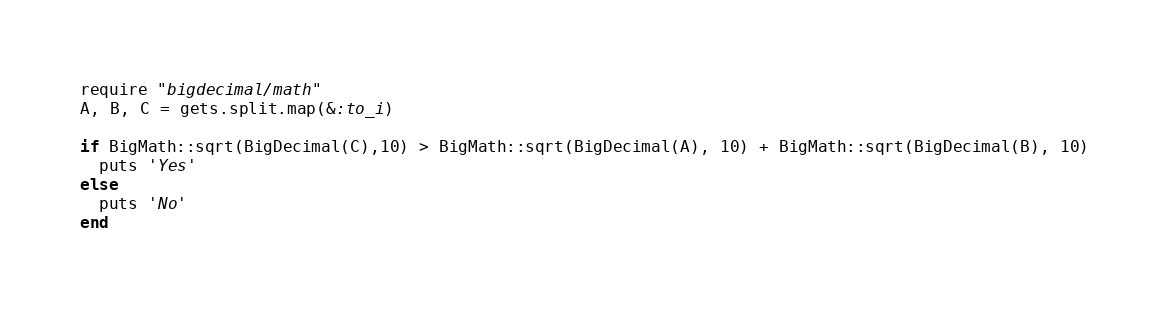Convert code to text. <code><loc_0><loc_0><loc_500><loc_500><_Ruby_>require "bigdecimal/math"
A, B, C = gets.split.map(&:to_i)

if BigMath::sqrt(BigDecimal(C),10) > BigMath::sqrt(BigDecimal(A), 10) + BigMath::sqrt(BigDecimal(B), 10)
  puts 'Yes'
else
  puts 'No'
end</code> 